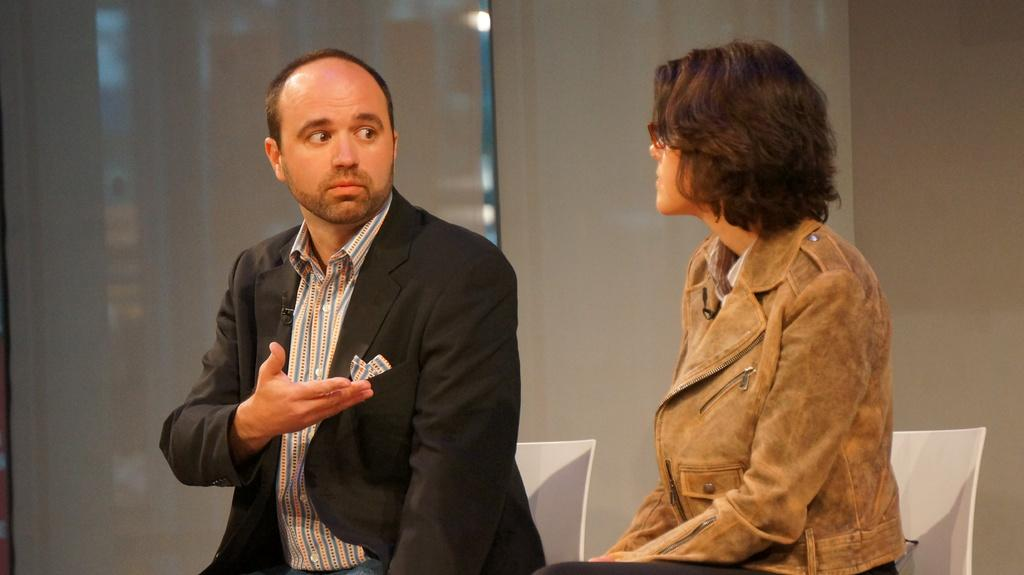What are the two people in the image doing? The man and woman are sitting in the image. What are they wearing? They are both wearing clothes. Can you describe the woman's appearance? The woman is wearing spectacles. What can be seen in the background of the image? There are curtains and a wall visible in the image. What type of recess can be seen in the image? There is no recess present in the image. How does the man feel about the woman's spectacles in the image? The image does not provide any information about the man's feelings towards the woman's spectacles. 